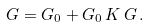Convert formula to latex. <formula><loc_0><loc_0><loc_500><loc_500>G = G _ { 0 } + G _ { 0 } \, K \, G \, .</formula> 